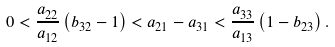<formula> <loc_0><loc_0><loc_500><loc_500>0 < \frac { a _ { 2 2 } } { a _ { 1 2 } } \left ( b _ { 3 2 } - 1 \right ) < a _ { 2 1 } - a _ { 3 1 } < \frac { a _ { 3 3 } } { a _ { 1 3 } } \left ( 1 - b _ { 2 3 } \right ) .</formula> 